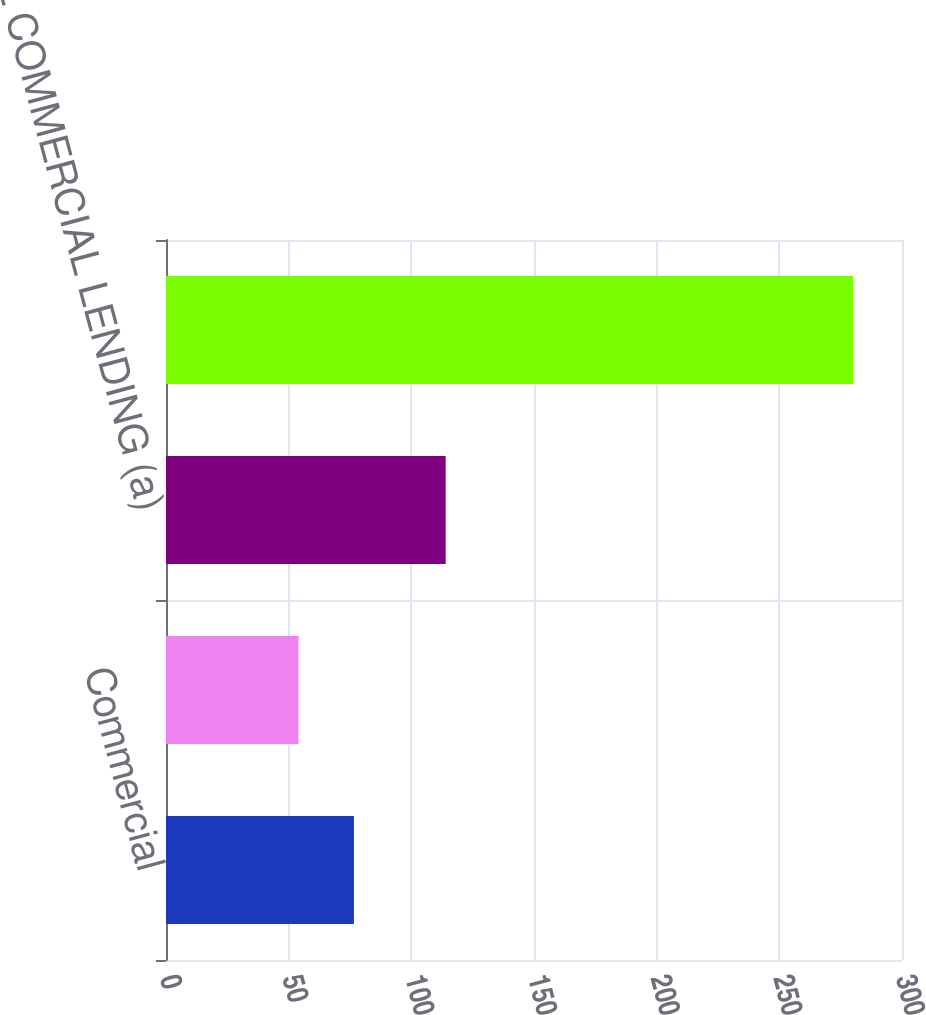<chart> <loc_0><loc_0><loc_500><loc_500><bar_chart><fcel>Commercial<fcel>Commercial real estate<fcel>TOTAL COMMERCIAL LENDING (a)<fcel>Total TDRs<nl><fcel>76.6<fcel>54<fcel>114<fcel>280<nl></chart> 